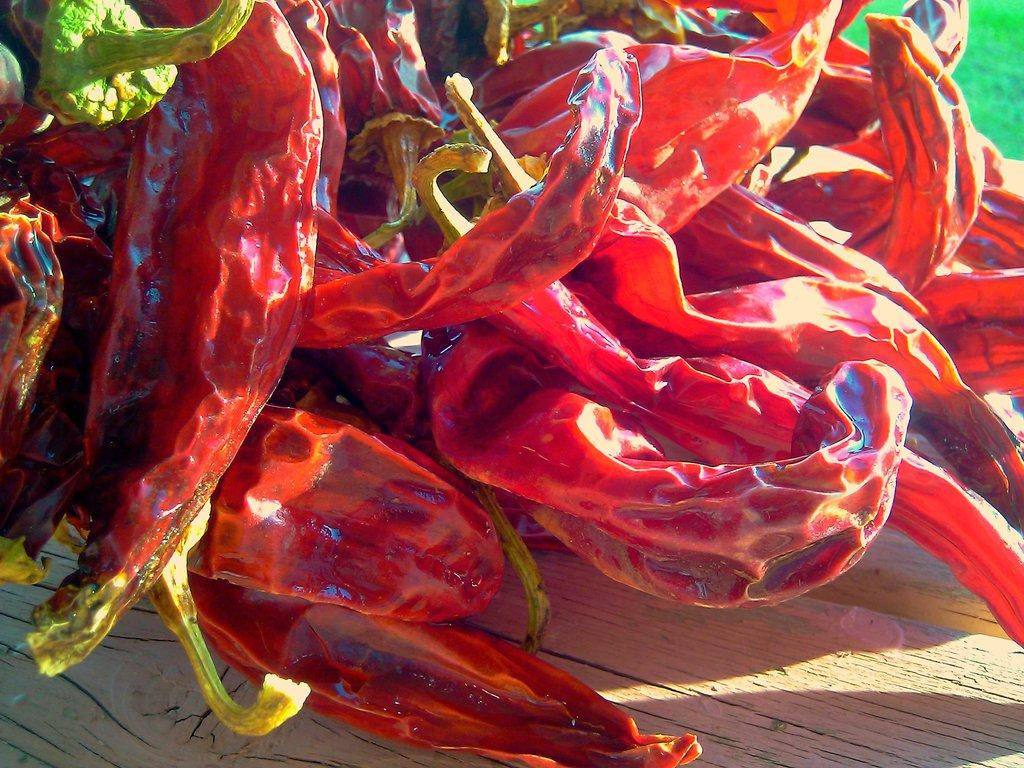What type of food item is present in the image? There are red chillies in the image. What is the color of the chillies? The red chillies are red in color. On what surface are the red chillies placed? The red chillies are on a wooden surface. How many rabbits can be seen playing with a match in the image? There are no rabbits or matches present in the image; it only features red chillies on a wooden surface. 